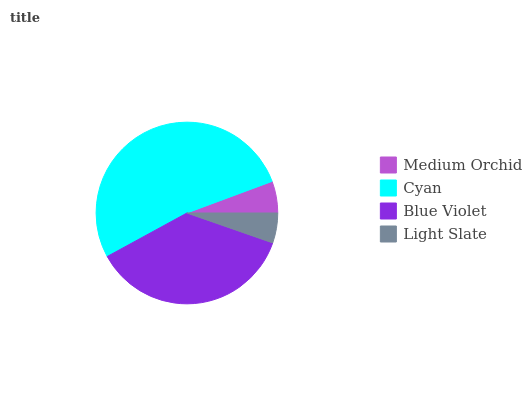Is Light Slate the minimum?
Answer yes or no. Yes. Is Cyan the maximum?
Answer yes or no. Yes. Is Blue Violet the minimum?
Answer yes or no. No. Is Blue Violet the maximum?
Answer yes or no. No. Is Cyan greater than Blue Violet?
Answer yes or no. Yes. Is Blue Violet less than Cyan?
Answer yes or no. Yes. Is Blue Violet greater than Cyan?
Answer yes or no. No. Is Cyan less than Blue Violet?
Answer yes or no. No. Is Blue Violet the high median?
Answer yes or no. Yes. Is Medium Orchid the low median?
Answer yes or no. Yes. Is Light Slate the high median?
Answer yes or no. No. Is Light Slate the low median?
Answer yes or no. No. 